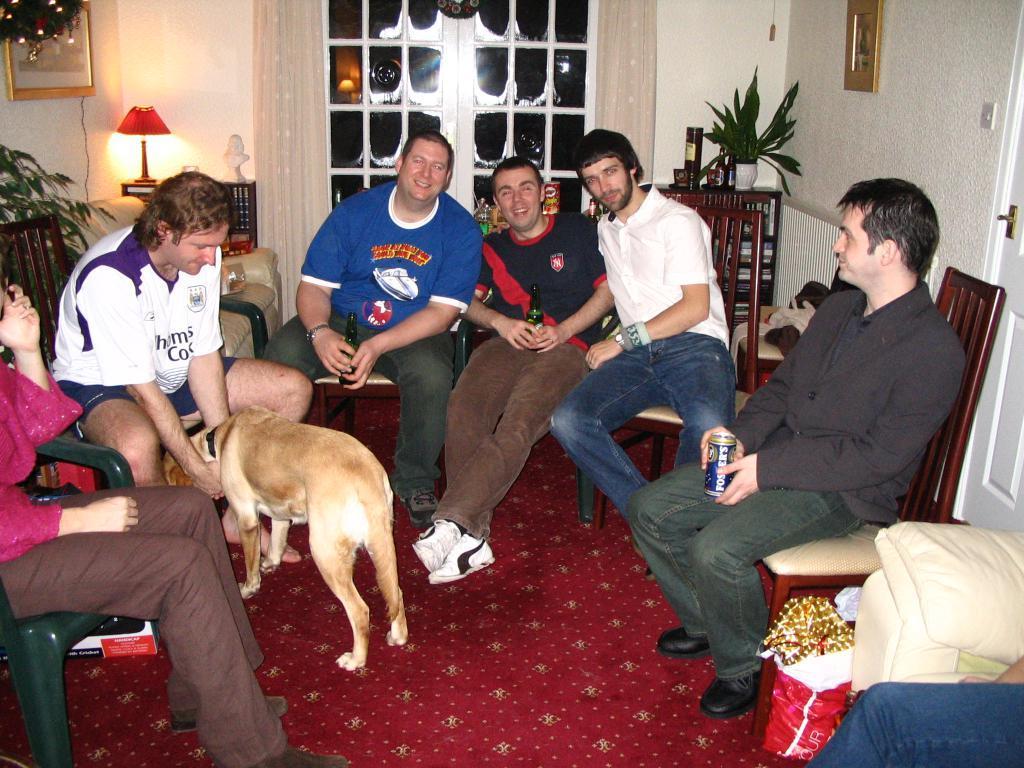Can you describe this image briefly? In this picture there are group of people who are sitting on the chair. There is a dog. There is a bottle, tin, cover, lamp, frame and flower pot on the table. There is a door. 